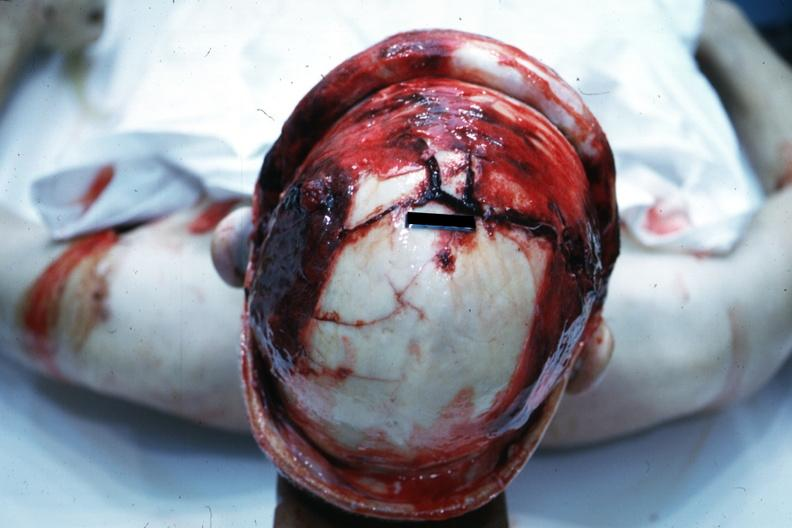what is present?
Answer the question using a single word or phrase. Bone, calvarium 